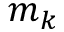Convert formula to latex. <formula><loc_0><loc_0><loc_500><loc_500>m _ { k }</formula> 